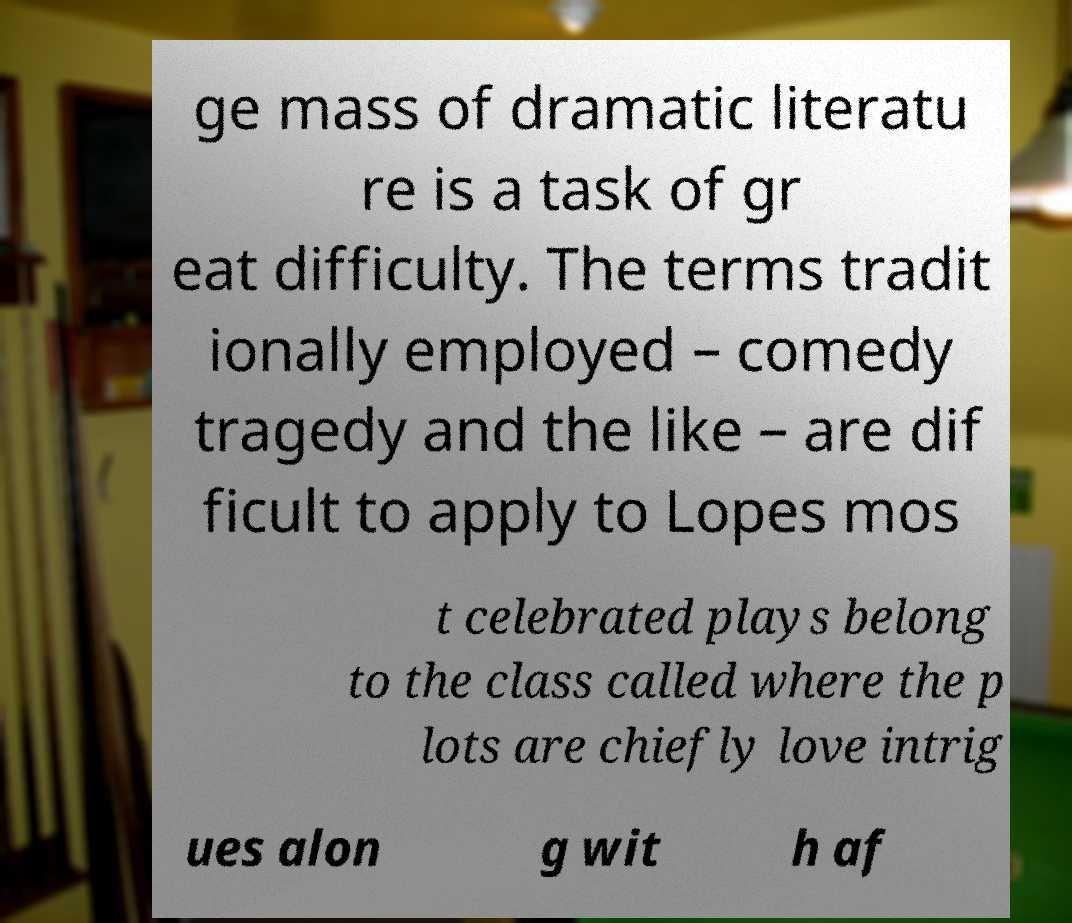Can you read and provide the text displayed in the image?This photo seems to have some interesting text. Can you extract and type it out for me? ge mass of dramatic literatu re is a task of gr eat difficulty. The terms tradit ionally employed – comedy tragedy and the like – are dif ficult to apply to Lopes mos t celebrated plays belong to the class called where the p lots are chiefly love intrig ues alon g wit h af 